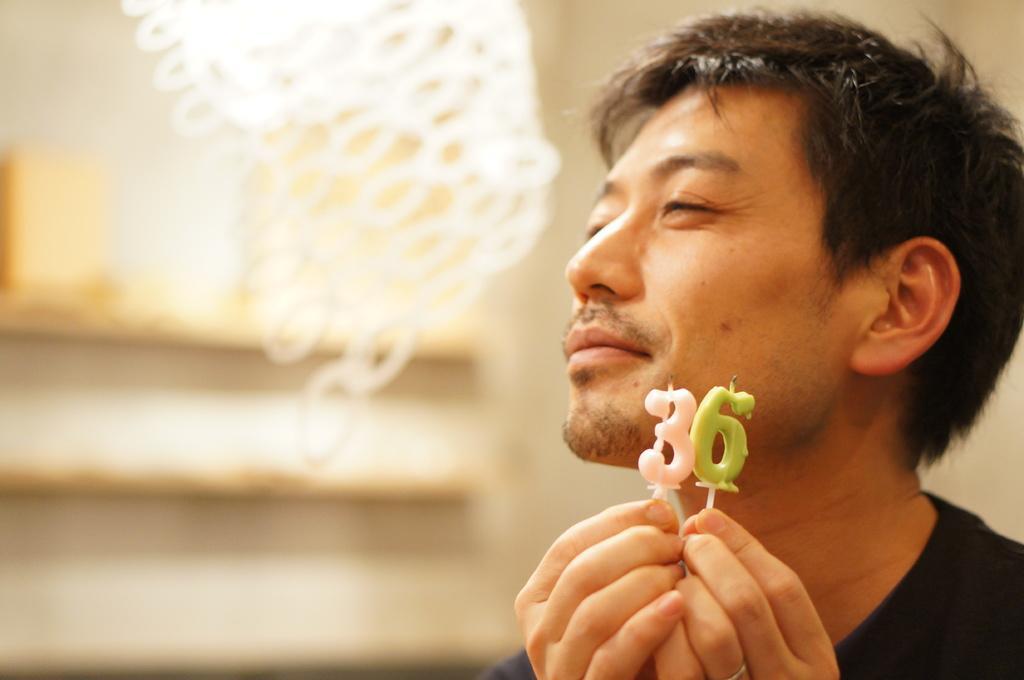In one or two sentences, can you explain what this image depicts? In the foreground of the image there is a person holding candles. In the background of the image there is a wall. 